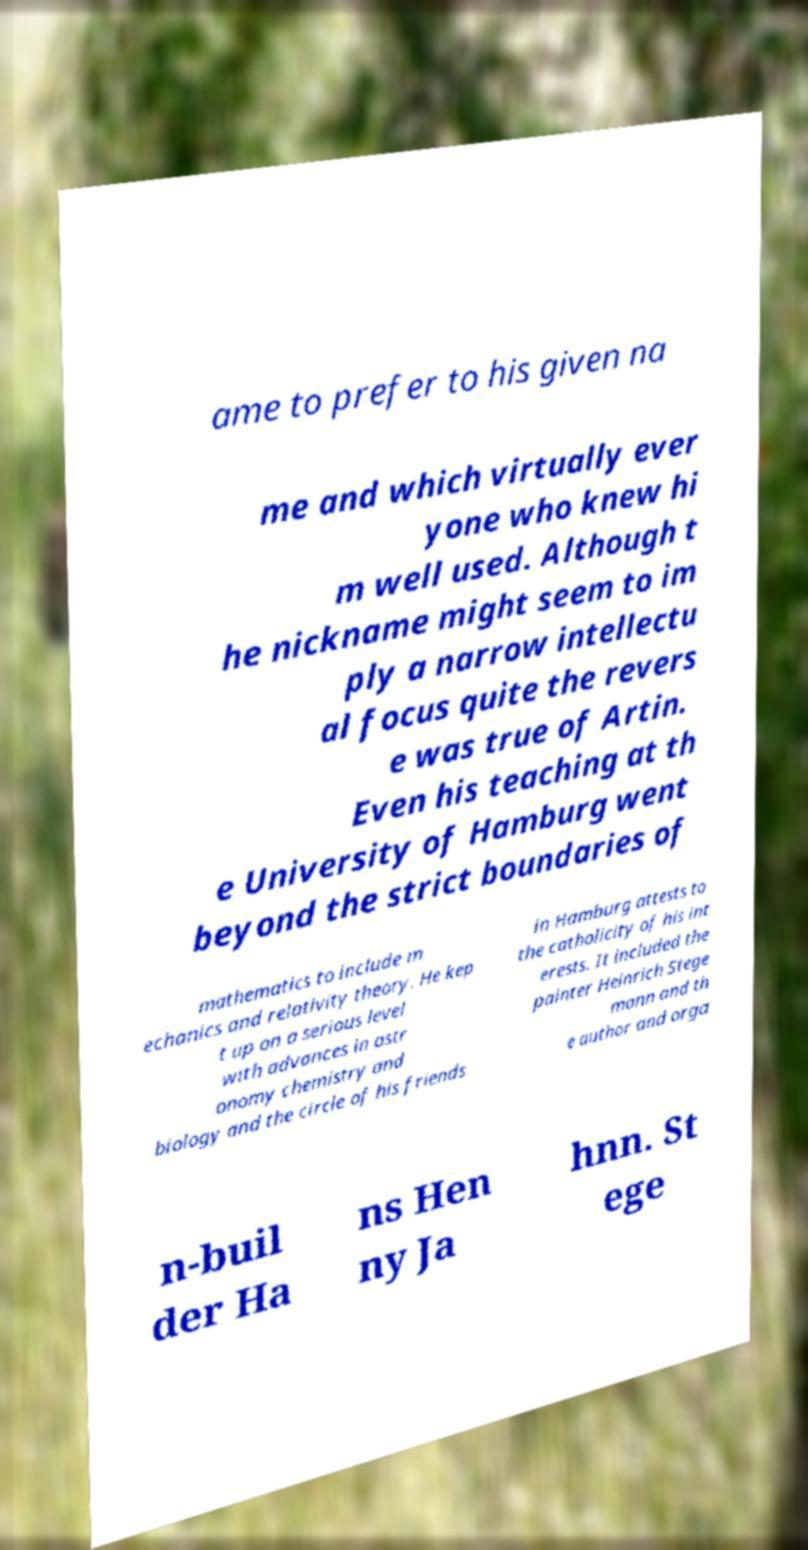Could you extract and type out the text from this image? ame to prefer to his given na me and which virtually ever yone who knew hi m well used. Although t he nickname might seem to im ply a narrow intellectu al focus quite the revers e was true of Artin. Even his teaching at th e University of Hamburg went beyond the strict boundaries of mathematics to include m echanics and relativity theory. He kep t up on a serious level with advances in astr onomy chemistry and biology and the circle of his friends in Hamburg attests to the catholicity of his int erests. It included the painter Heinrich Stege mann and th e author and orga n-buil der Ha ns Hen ny Ja hnn. St ege 